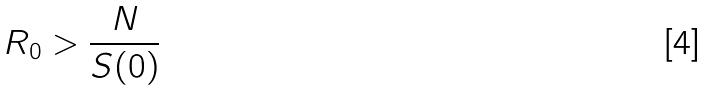Convert formula to latex. <formula><loc_0><loc_0><loc_500><loc_500>R _ { 0 } > \frac { N } { S ( 0 ) }</formula> 